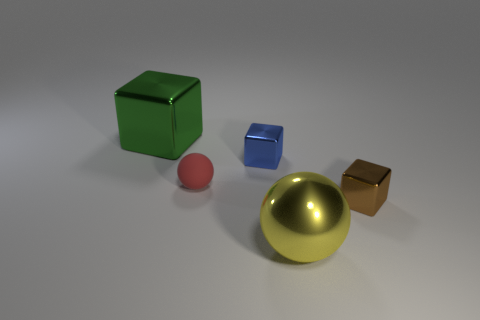Is the number of purple rubber cylinders greater than the number of brown cubes?
Offer a very short reply. No. What number of objects are small metal cubes to the right of the yellow sphere or large brown balls?
Offer a terse response. 1. There is a big shiny object behind the red matte sphere; what number of tiny blue blocks are left of it?
Your answer should be compact. 0. There is a shiny block on the left side of the tiny cube that is left of the small metal cube that is in front of the red thing; what size is it?
Offer a very short reply. Large. There is a tiny shiny object that is left of the large metallic ball; is its color the same as the rubber thing?
Your answer should be compact. No. The yellow metal thing that is the same shape as the red rubber thing is what size?
Provide a short and direct response. Large. How many objects are either cubes that are to the right of the green metal object or spheres that are to the right of the matte sphere?
Your answer should be very brief. 3. What is the shape of the large object that is on the right side of the large thing that is left of the red rubber sphere?
Your response must be concise. Sphere. Is there any other thing of the same color as the tiny rubber thing?
Give a very brief answer. No. Are there any other things that are the same size as the green shiny block?
Keep it short and to the point. Yes. 